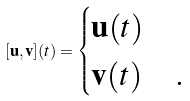Convert formula to latex. <formula><loc_0><loc_0><loc_500><loc_500>[ \mathbf u , \mathbf v ] ( t ) = \begin{cases} \mathbf u ( t ) & \\ \mathbf v ( t ) & . \end{cases}</formula> 